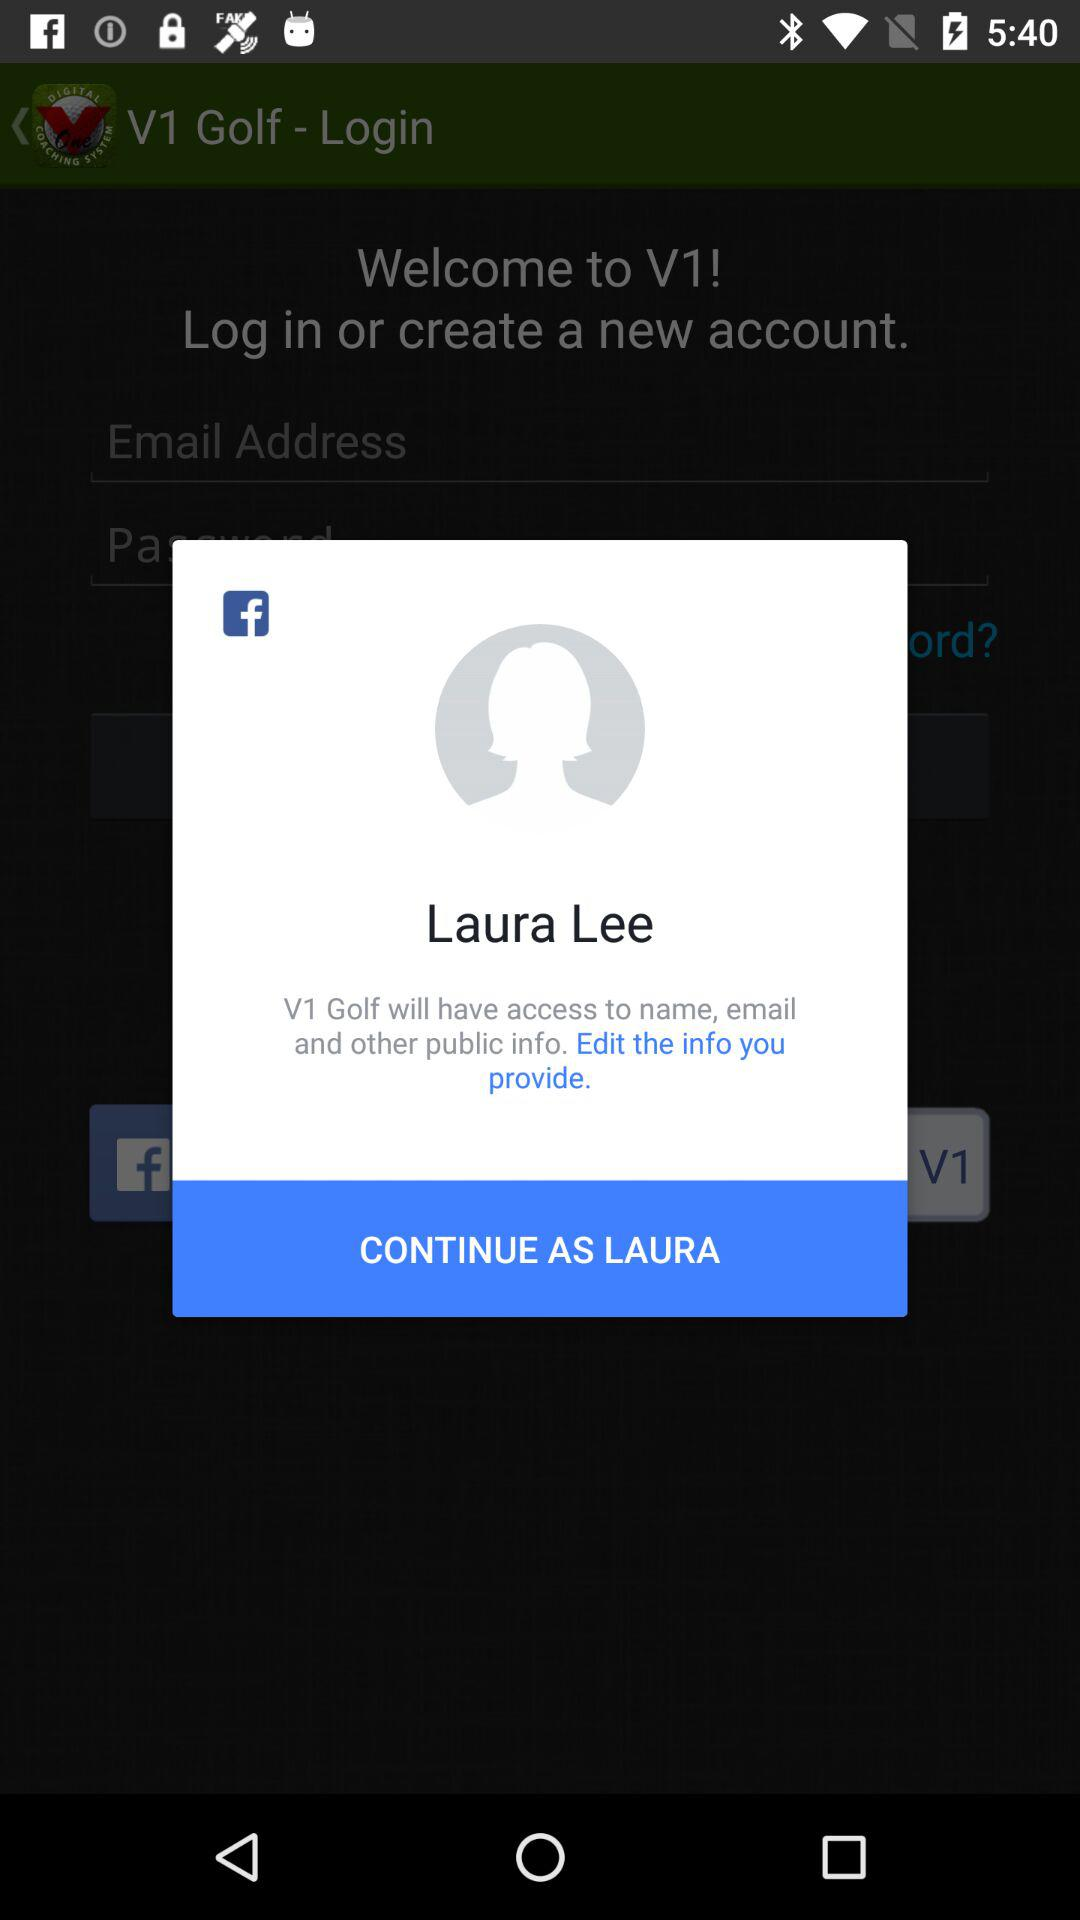Through which applications can we log in? You can log in through "Facebook". 